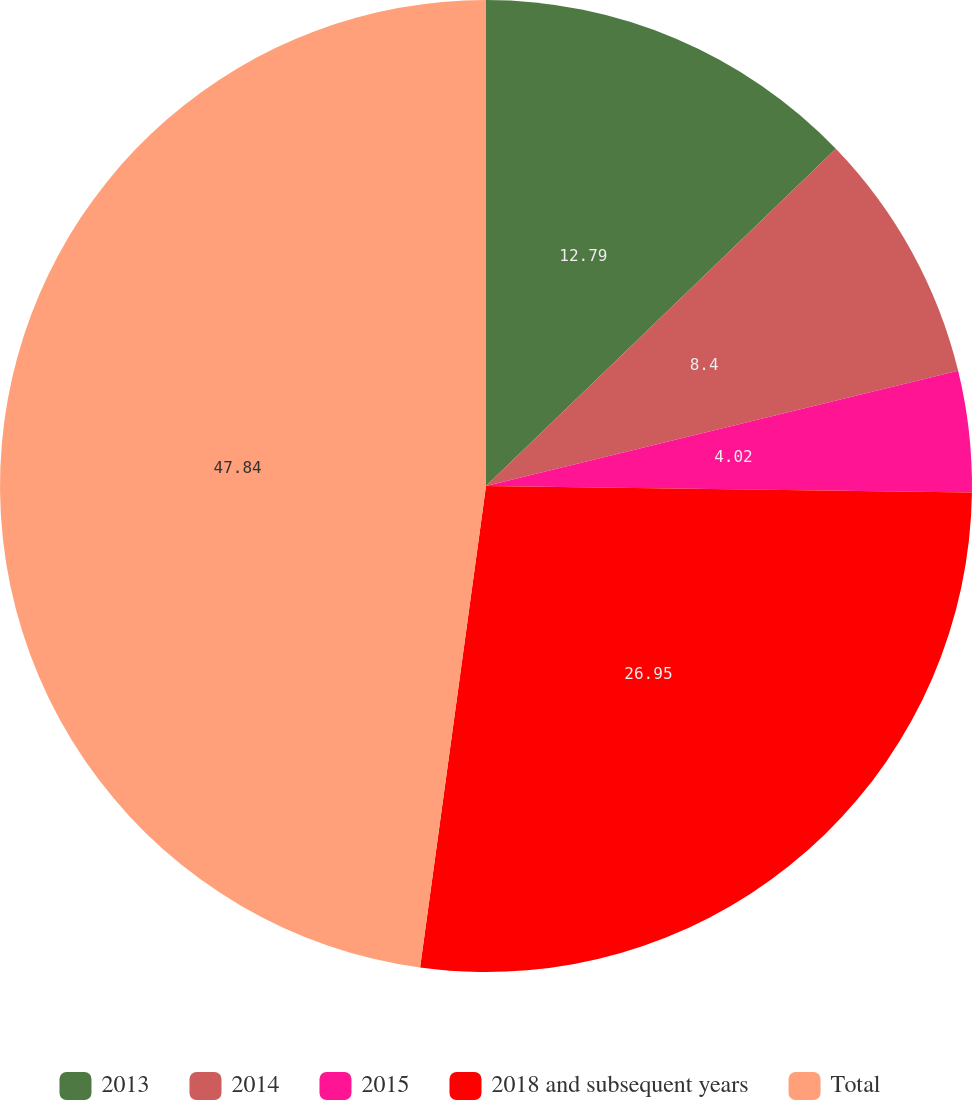Convert chart to OTSL. <chart><loc_0><loc_0><loc_500><loc_500><pie_chart><fcel>2013<fcel>2014<fcel>2015<fcel>2018 and subsequent years<fcel>Total<nl><fcel>12.79%<fcel>8.4%<fcel>4.02%<fcel>26.95%<fcel>47.83%<nl></chart> 